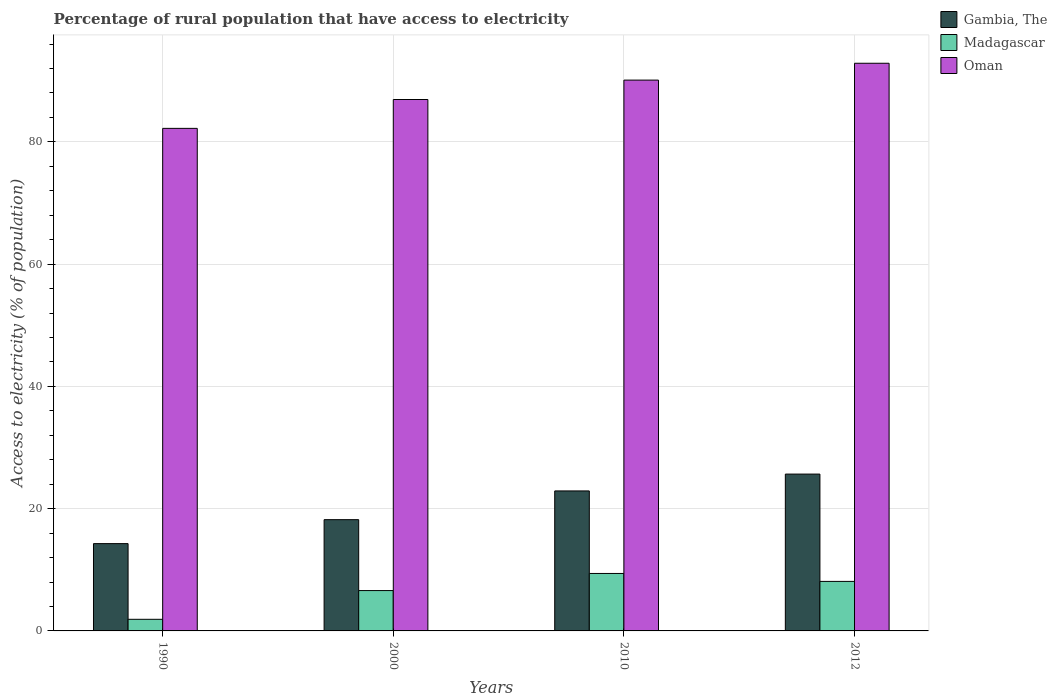How many groups of bars are there?
Your answer should be compact. 4. Are the number of bars on each tick of the X-axis equal?
Offer a terse response. Yes. How many bars are there on the 1st tick from the left?
Give a very brief answer. 3. How many bars are there on the 3rd tick from the right?
Your answer should be compact. 3. What is the label of the 1st group of bars from the left?
Give a very brief answer. 1990. What is the percentage of rural population that have access to electricity in Oman in 2010?
Your answer should be compact. 90.1. Across all years, what is the maximum percentage of rural population that have access to electricity in Oman?
Make the answer very short. 92.85. Across all years, what is the minimum percentage of rural population that have access to electricity in Oman?
Provide a succinct answer. 82.2. What is the total percentage of rural population that have access to electricity in Madagascar in the graph?
Provide a short and direct response. 26. What is the difference between the percentage of rural population that have access to electricity in Madagascar in 2000 and that in 2010?
Offer a very short reply. -2.8. What is the difference between the percentage of rural population that have access to electricity in Oman in 2000 and the percentage of rural population that have access to electricity in Gambia, The in 1990?
Your answer should be compact. 72.65. What is the average percentage of rural population that have access to electricity in Oman per year?
Your answer should be compact. 88.02. In the year 1990, what is the difference between the percentage of rural population that have access to electricity in Oman and percentage of rural population that have access to electricity in Madagascar?
Offer a very short reply. 80.3. In how many years, is the percentage of rural population that have access to electricity in Madagascar greater than 36 %?
Keep it short and to the point. 0. What is the ratio of the percentage of rural population that have access to electricity in Gambia, The in 2000 to that in 2010?
Your answer should be compact. 0.79. Is the percentage of rural population that have access to electricity in Oman in 2000 less than that in 2012?
Offer a very short reply. Yes. What is the difference between the highest and the second highest percentage of rural population that have access to electricity in Madagascar?
Give a very brief answer. 1.3. What is the difference between the highest and the lowest percentage of rural population that have access to electricity in Madagascar?
Offer a very short reply. 7.5. In how many years, is the percentage of rural population that have access to electricity in Oman greater than the average percentage of rural population that have access to electricity in Oman taken over all years?
Keep it short and to the point. 2. Is the sum of the percentage of rural population that have access to electricity in Madagascar in 2000 and 2010 greater than the maximum percentage of rural population that have access to electricity in Oman across all years?
Your answer should be compact. No. What does the 2nd bar from the left in 2000 represents?
Provide a succinct answer. Madagascar. What does the 2nd bar from the right in 2012 represents?
Make the answer very short. Madagascar. How many bars are there?
Provide a succinct answer. 12. What is the difference between two consecutive major ticks on the Y-axis?
Make the answer very short. 20. Are the values on the major ticks of Y-axis written in scientific E-notation?
Provide a short and direct response. No. Does the graph contain any zero values?
Ensure brevity in your answer.  No. Does the graph contain grids?
Make the answer very short. Yes. Where does the legend appear in the graph?
Make the answer very short. Top right. What is the title of the graph?
Offer a terse response. Percentage of rural population that have access to electricity. Does "Algeria" appear as one of the legend labels in the graph?
Offer a terse response. No. What is the label or title of the X-axis?
Keep it short and to the point. Years. What is the label or title of the Y-axis?
Provide a short and direct response. Access to electricity (% of population). What is the Access to electricity (% of population) of Gambia, The in 1990?
Give a very brief answer. 14.28. What is the Access to electricity (% of population) in Oman in 1990?
Keep it short and to the point. 82.2. What is the Access to electricity (% of population) in Oman in 2000?
Ensure brevity in your answer.  86.93. What is the Access to electricity (% of population) in Gambia, The in 2010?
Give a very brief answer. 22.9. What is the Access to electricity (% of population) of Oman in 2010?
Offer a terse response. 90.1. What is the Access to electricity (% of population) of Gambia, The in 2012?
Offer a terse response. 25.65. What is the Access to electricity (% of population) of Oman in 2012?
Provide a succinct answer. 92.85. Across all years, what is the maximum Access to electricity (% of population) in Gambia, The?
Offer a very short reply. 25.65. Across all years, what is the maximum Access to electricity (% of population) of Oman?
Ensure brevity in your answer.  92.85. Across all years, what is the minimum Access to electricity (% of population) of Gambia, The?
Ensure brevity in your answer.  14.28. Across all years, what is the minimum Access to electricity (% of population) of Oman?
Offer a terse response. 82.2. What is the total Access to electricity (% of population) of Gambia, The in the graph?
Ensure brevity in your answer.  81.03. What is the total Access to electricity (% of population) in Oman in the graph?
Ensure brevity in your answer.  352.08. What is the difference between the Access to electricity (% of population) in Gambia, The in 1990 and that in 2000?
Keep it short and to the point. -3.92. What is the difference between the Access to electricity (% of population) in Oman in 1990 and that in 2000?
Provide a succinct answer. -4.72. What is the difference between the Access to electricity (% of population) in Gambia, The in 1990 and that in 2010?
Ensure brevity in your answer.  -8.62. What is the difference between the Access to electricity (% of population) in Madagascar in 1990 and that in 2010?
Your response must be concise. -7.5. What is the difference between the Access to electricity (% of population) in Oman in 1990 and that in 2010?
Your answer should be very brief. -7.9. What is the difference between the Access to electricity (% of population) in Gambia, The in 1990 and that in 2012?
Ensure brevity in your answer.  -11.38. What is the difference between the Access to electricity (% of population) in Oman in 1990 and that in 2012?
Ensure brevity in your answer.  -10.65. What is the difference between the Access to electricity (% of population) in Gambia, The in 2000 and that in 2010?
Provide a succinct answer. -4.7. What is the difference between the Access to electricity (% of population) of Madagascar in 2000 and that in 2010?
Offer a terse response. -2.8. What is the difference between the Access to electricity (% of population) of Oman in 2000 and that in 2010?
Provide a short and direct response. -3.17. What is the difference between the Access to electricity (% of population) of Gambia, The in 2000 and that in 2012?
Your answer should be very brief. -7.45. What is the difference between the Access to electricity (% of population) of Oman in 2000 and that in 2012?
Offer a very short reply. -5.93. What is the difference between the Access to electricity (% of population) of Gambia, The in 2010 and that in 2012?
Your answer should be compact. -2.75. What is the difference between the Access to electricity (% of population) in Madagascar in 2010 and that in 2012?
Make the answer very short. 1.3. What is the difference between the Access to electricity (% of population) in Oman in 2010 and that in 2012?
Give a very brief answer. -2.75. What is the difference between the Access to electricity (% of population) in Gambia, The in 1990 and the Access to electricity (% of population) in Madagascar in 2000?
Provide a succinct answer. 7.68. What is the difference between the Access to electricity (% of population) of Gambia, The in 1990 and the Access to electricity (% of population) of Oman in 2000?
Offer a terse response. -72.65. What is the difference between the Access to electricity (% of population) in Madagascar in 1990 and the Access to electricity (% of population) in Oman in 2000?
Your answer should be very brief. -85.03. What is the difference between the Access to electricity (% of population) in Gambia, The in 1990 and the Access to electricity (% of population) in Madagascar in 2010?
Your answer should be very brief. 4.88. What is the difference between the Access to electricity (% of population) of Gambia, The in 1990 and the Access to electricity (% of population) of Oman in 2010?
Your answer should be compact. -75.82. What is the difference between the Access to electricity (% of population) in Madagascar in 1990 and the Access to electricity (% of population) in Oman in 2010?
Ensure brevity in your answer.  -88.2. What is the difference between the Access to electricity (% of population) in Gambia, The in 1990 and the Access to electricity (% of population) in Madagascar in 2012?
Your response must be concise. 6.18. What is the difference between the Access to electricity (% of population) of Gambia, The in 1990 and the Access to electricity (% of population) of Oman in 2012?
Give a very brief answer. -78.58. What is the difference between the Access to electricity (% of population) in Madagascar in 1990 and the Access to electricity (% of population) in Oman in 2012?
Your answer should be compact. -90.95. What is the difference between the Access to electricity (% of population) of Gambia, The in 2000 and the Access to electricity (% of population) of Oman in 2010?
Your answer should be compact. -71.9. What is the difference between the Access to electricity (% of population) in Madagascar in 2000 and the Access to electricity (% of population) in Oman in 2010?
Ensure brevity in your answer.  -83.5. What is the difference between the Access to electricity (% of population) of Gambia, The in 2000 and the Access to electricity (% of population) of Madagascar in 2012?
Offer a very short reply. 10.1. What is the difference between the Access to electricity (% of population) of Gambia, The in 2000 and the Access to electricity (% of population) of Oman in 2012?
Offer a terse response. -74.65. What is the difference between the Access to electricity (% of population) in Madagascar in 2000 and the Access to electricity (% of population) in Oman in 2012?
Give a very brief answer. -86.25. What is the difference between the Access to electricity (% of population) of Gambia, The in 2010 and the Access to electricity (% of population) of Madagascar in 2012?
Offer a very short reply. 14.8. What is the difference between the Access to electricity (% of population) of Gambia, The in 2010 and the Access to electricity (% of population) of Oman in 2012?
Your answer should be compact. -69.95. What is the difference between the Access to electricity (% of population) in Madagascar in 2010 and the Access to electricity (% of population) in Oman in 2012?
Your answer should be compact. -83.45. What is the average Access to electricity (% of population) in Gambia, The per year?
Ensure brevity in your answer.  20.26. What is the average Access to electricity (% of population) in Oman per year?
Offer a very short reply. 88.02. In the year 1990, what is the difference between the Access to electricity (% of population) in Gambia, The and Access to electricity (% of population) in Madagascar?
Provide a succinct answer. 12.38. In the year 1990, what is the difference between the Access to electricity (% of population) in Gambia, The and Access to electricity (% of population) in Oman?
Ensure brevity in your answer.  -67.92. In the year 1990, what is the difference between the Access to electricity (% of population) of Madagascar and Access to electricity (% of population) of Oman?
Your response must be concise. -80.3. In the year 2000, what is the difference between the Access to electricity (% of population) in Gambia, The and Access to electricity (% of population) in Madagascar?
Keep it short and to the point. 11.6. In the year 2000, what is the difference between the Access to electricity (% of population) in Gambia, The and Access to electricity (% of population) in Oman?
Give a very brief answer. -68.73. In the year 2000, what is the difference between the Access to electricity (% of population) in Madagascar and Access to electricity (% of population) in Oman?
Make the answer very short. -80.33. In the year 2010, what is the difference between the Access to electricity (% of population) in Gambia, The and Access to electricity (% of population) in Madagascar?
Your answer should be very brief. 13.5. In the year 2010, what is the difference between the Access to electricity (% of population) in Gambia, The and Access to electricity (% of population) in Oman?
Provide a succinct answer. -67.2. In the year 2010, what is the difference between the Access to electricity (% of population) of Madagascar and Access to electricity (% of population) of Oman?
Provide a short and direct response. -80.7. In the year 2012, what is the difference between the Access to electricity (% of population) in Gambia, The and Access to electricity (% of population) in Madagascar?
Make the answer very short. 17.55. In the year 2012, what is the difference between the Access to electricity (% of population) in Gambia, The and Access to electricity (% of population) in Oman?
Keep it short and to the point. -67.2. In the year 2012, what is the difference between the Access to electricity (% of population) in Madagascar and Access to electricity (% of population) in Oman?
Your answer should be very brief. -84.75. What is the ratio of the Access to electricity (% of population) in Gambia, The in 1990 to that in 2000?
Provide a succinct answer. 0.78. What is the ratio of the Access to electricity (% of population) in Madagascar in 1990 to that in 2000?
Make the answer very short. 0.29. What is the ratio of the Access to electricity (% of population) of Oman in 1990 to that in 2000?
Offer a very short reply. 0.95. What is the ratio of the Access to electricity (% of population) of Gambia, The in 1990 to that in 2010?
Provide a succinct answer. 0.62. What is the ratio of the Access to electricity (% of population) in Madagascar in 1990 to that in 2010?
Your response must be concise. 0.2. What is the ratio of the Access to electricity (% of population) in Oman in 1990 to that in 2010?
Your answer should be compact. 0.91. What is the ratio of the Access to electricity (% of population) of Gambia, The in 1990 to that in 2012?
Keep it short and to the point. 0.56. What is the ratio of the Access to electricity (% of population) of Madagascar in 1990 to that in 2012?
Make the answer very short. 0.23. What is the ratio of the Access to electricity (% of population) in Oman in 1990 to that in 2012?
Provide a succinct answer. 0.89. What is the ratio of the Access to electricity (% of population) in Gambia, The in 2000 to that in 2010?
Ensure brevity in your answer.  0.79. What is the ratio of the Access to electricity (% of population) of Madagascar in 2000 to that in 2010?
Make the answer very short. 0.7. What is the ratio of the Access to electricity (% of population) in Oman in 2000 to that in 2010?
Make the answer very short. 0.96. What is the ratio of the Access to electricity (% of population) in Gambia, The in 2000 to that in 2012?
Your answer should be compact. 0.71. What is the ratio of the Access to electricity (% of population) in Madagascar in 2000 to that in 2012?
Provide a succinct answer. 0.81. What is the ratio of the Access to electricity (% of population) in Oman in 2000 to that in 2012?
Give a very brief answer. 0.94. What is the ratio of the Access to electricity (% of population) of Gambia, The in 2010 to that in 2012?
Ensure brevity in your answer.  0.89. What is the ratio of the Access to electricity (% of population) in Madagascar in 2010 to that in 2012?
Give a very brief answer. 1.16. What is the ratio of the Access to electricity (% of population) in Oman in 2010 to that in 2012?
Offer a very short reply. 0.97. What is the difference between the highest and the second highest Access to electricity (% of population) of Gambia, The?
Your response must be concise. 2.75. What is the difference between the highest and the second highest Access to electricity (% of population) of Oman?
Give a very brief answer. 2.75. What is the difference between the highest and the lowest Access to electricity (% of population) in Gambia, The?
Offer a terse response. 11.38. What is the difference between the highest and the lowest Access to electricity (% of population) in Oman?
Provide a succinct answer. 10.65. 